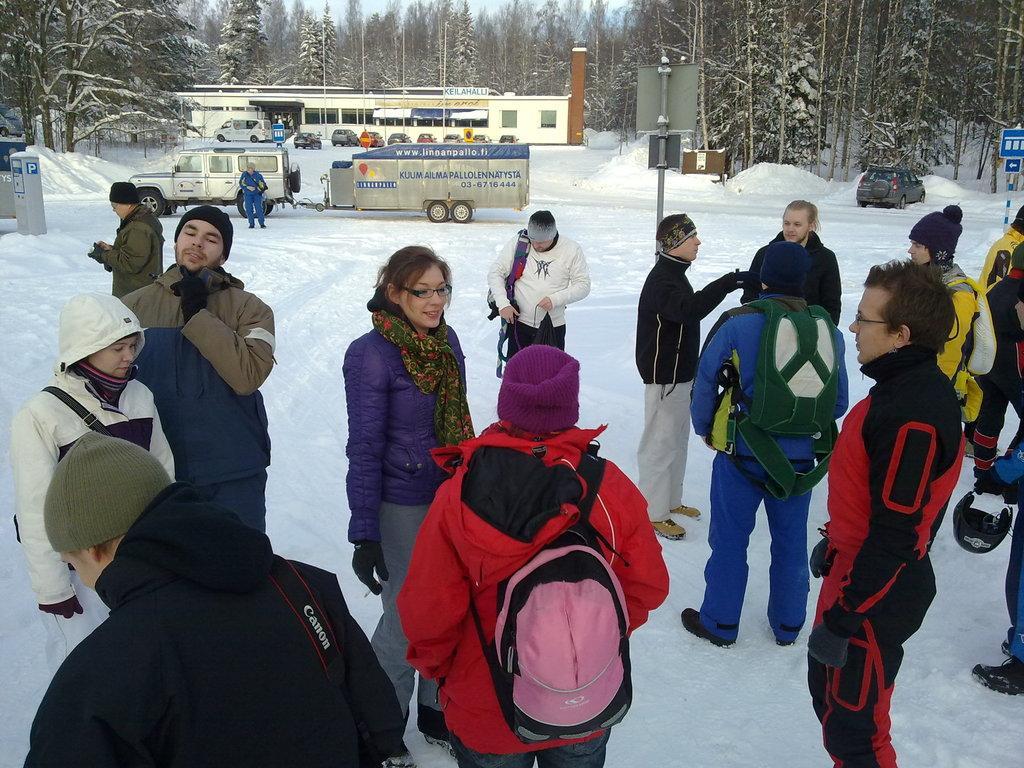How would you summarize this image in a sentence or two? In the picture I can see a group of people are standing on the snow among them some are carrying bags. In the background I can see vehicles, trees, boards, the sky and some other objects. 